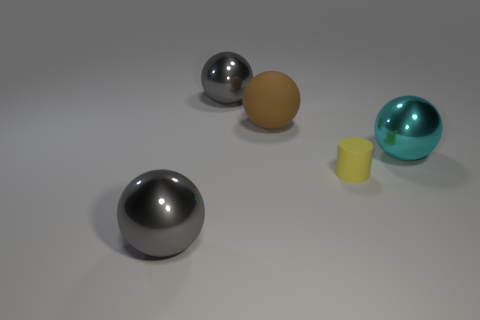Add 3 shiny balls. How many objects exist? 8 Subtract all cylinders. How many objects are left? 4 Subtract 0 purple cylinders. How many objects are left? 5 Subtract all tiny cyan matte cubes. Subtract all large brown rubber objects. How many objects are left? 4 Add 4 big things. How many big things are left? 8 Add 4 tiny purple rubber spheres. How many tiny purple rubber spheres exist? 4 